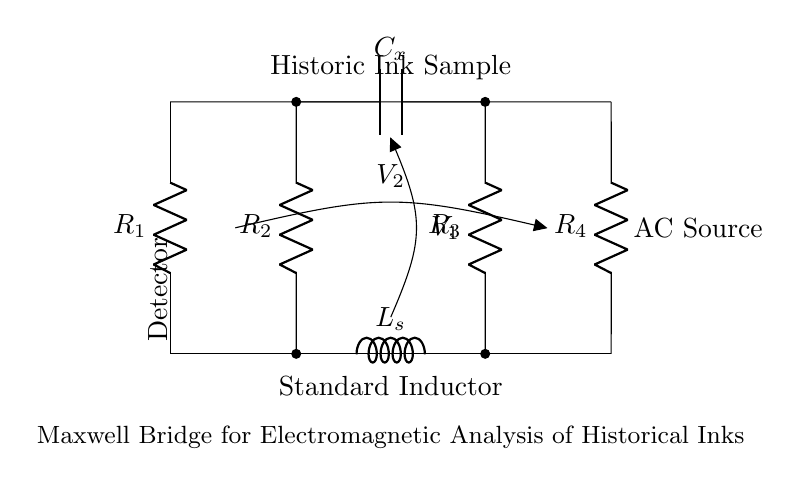What are the four resistors labeled in this circuit? The circuit diagram shows four resistors labeled as R1, R2, R3, and R4. Each component is visually represented with a label adjacent to it for easy identification.
Answer: R1, R2, R3, R4 What is the component labeled C in the circuit? The component labeled C in the circuit diagram is a capacitor, indicated by the symbol for a capacitor and the label Cx. It is placed between two resistors.
Answer: Capacitor How is the voltage across V1 connected in the circuit? V1 is connected across the two horizontal lines where the two resistors R2 and R3 are located. This means it measures the potential difference between these two points.
Answer: Parallel to R2 and R3 What type of circuit configuration is employed in this Maxwell bridge? The circuit uses a bridge configuration, which is characteristic of Maxwell bridges used for measuring inductance and comparing it against a known standard. The arrangement specifically allows for balancing the bridge.
Answer: Bridge What does the component L represent in this circuit? The component L represents an inductor which is standard in Maxwell bridges to balance against the inductive properties of the ink sample. Its placement as Ls below R2 indicates its role in measuring electromagnetic properties.
Answer: Inductor How does the AC source relate to the overall circuit operation? The AC source provides alternating current necessary for the operation of the Maxwell bridge, allowing for the measurement of both inductive and capacitive properties in the circuit. This type of current is essential for the bridge's function.
Answer: Alternating current What is the purpose of the Historic Ink Sample in this configuration? The Historic Ink Sample serves as the variable element whose electromagnetic properties are being studied in conjunction with the known inductance from Ls. The purpose is to analyze how historical inks respond to electromagnetic fields.
Answer: Study of inks 